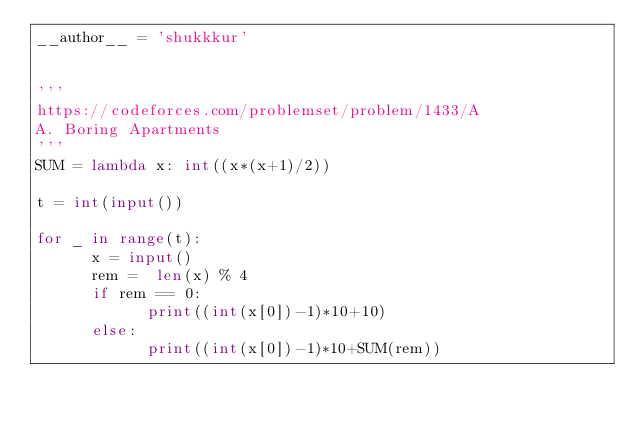<code> <loc_0><loc_0><loc_500><loc_500><_Python_>__author__ = 'shukkkur'


'''
https://codeforces.com/problemset/problem/1433/A
A. Boring Apartments
'''
SUM = lambda x: int((x*(x+1)/2))

t = int(input())

for _ in range(t):
      x = input()
      rem =  len(x) % 4
      if rem == 0:
            print((int(x[0])-1)*10+10)
      else:
            print((int(x[0])-1)*10+SUM(rem))



      
</code> 